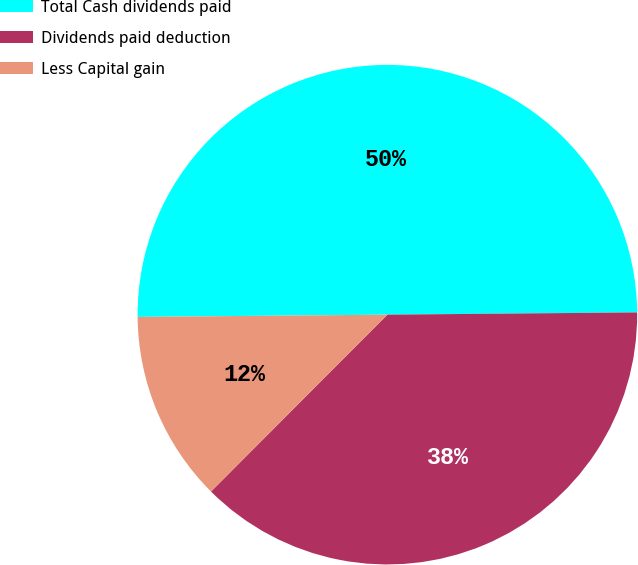Convert chart. <chart><loc_0><loc_0><loc_500><loc_500><pie_chart><fcel>Total Cash dividends paid<fcel>Dividends paid deduction<fcel>Less Capital gain<nl><fcel>50.0%<fcel>37.62%<fcel>12.38%<nl></chart> 